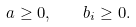Convert formula to latex. <formula><loc_0><loc_0><loc_500><loc_500>a \geq 0 , \quad b _ { i } \geq 0 .</formula> 